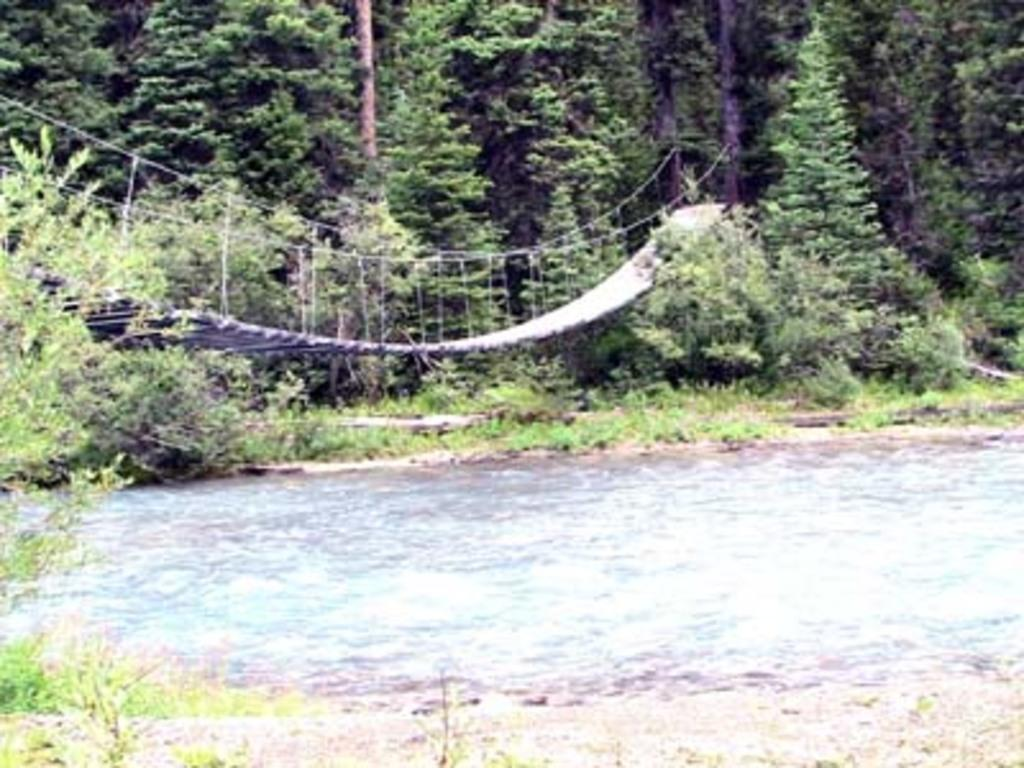What is the main structure in the center of the image? There is a hanging bridge in the center of the image. What can be seen at the bottom of the image? Water and plants are visible at the bottom of the image. What type of vegetation is present in the background of the image? There are trees in the background of the image. What type of pencil can be seen hanging from the bridge in the image? There is no pencil present in the image, and therefore no such object can be observed hanging from the bridge. 